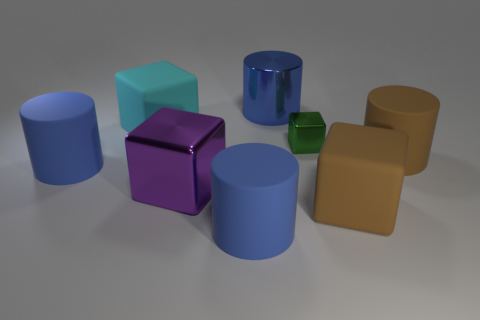Are there any large blue objects on the right side of the tiny green cube? no 